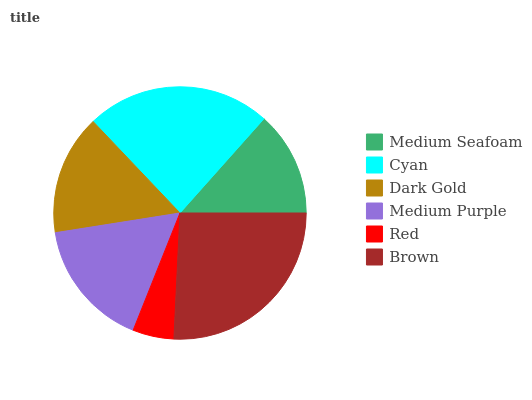Is Red the minimum?
Answer yes or no. Yes. Is Brown the maximum?
Answer yes or no. Yes. Is Cyan the minimum?
Answer yes or no. No. Is Cyan the maximum?
Answer yes or no. No. Is Cyan greater than Medium Seafoam?
Answer yes or no. Yes. Is Medium Seafoam less than Cyan?
Answer yes or no. Yes. Is Medium Seafoam greater than Cyan?
Answer yes or no. No. Is Cyan less than Medium Seafoam?
Answer yes or no. No. Is Medium Purple the high median?
Answer yes or no. Yes. Is Dark Gold the low median?
Answer yes or no. Yes. Is Cyan the high median?
Answer yes or no. No. Is Cyan the low median?
Answer yes or no. No. 